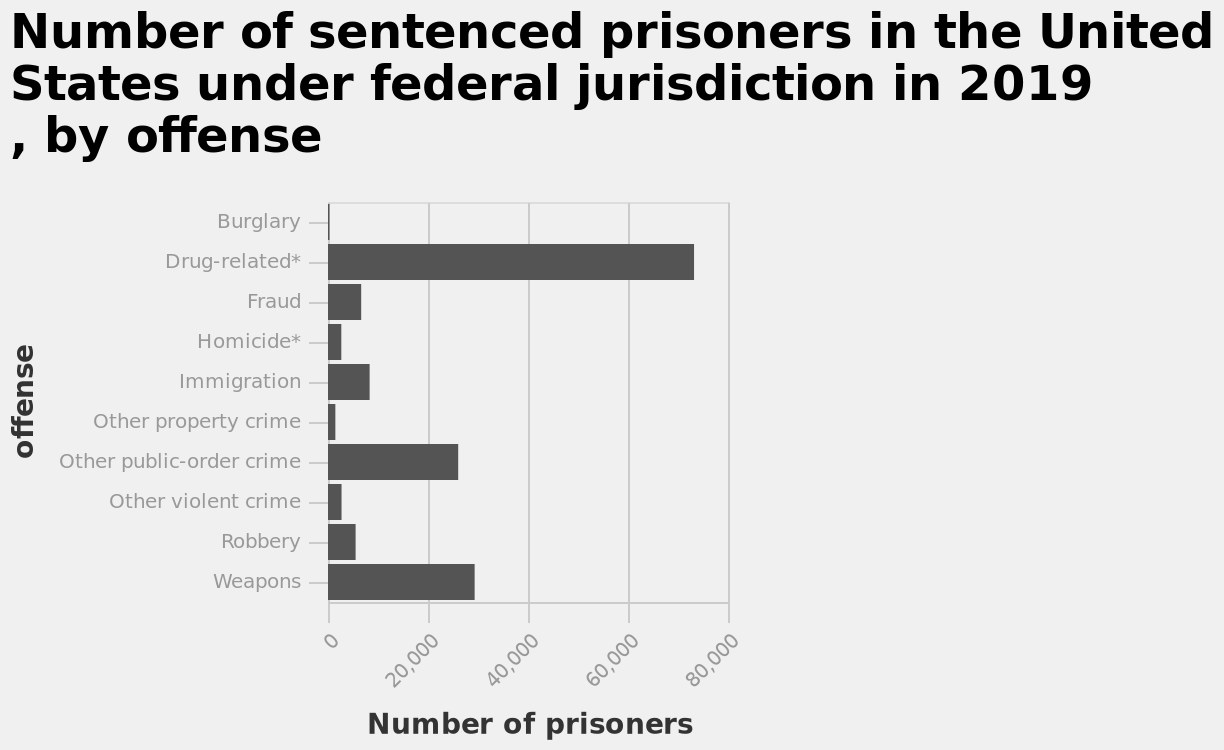<image>
please summary the statistics and relations of the chart The drug sentenced are a large number comparing with the other one. Describe the following image in detail This bar chart is labeled Number of sentenced prisoners in the United States under federal jurisdiction in 2019 , by offense. A linear scale with a minimum of 0 and a maximum of 80,000 can be seen along the x-axis, labeled Number of prisoners. On the y-axis, offense is defined. 